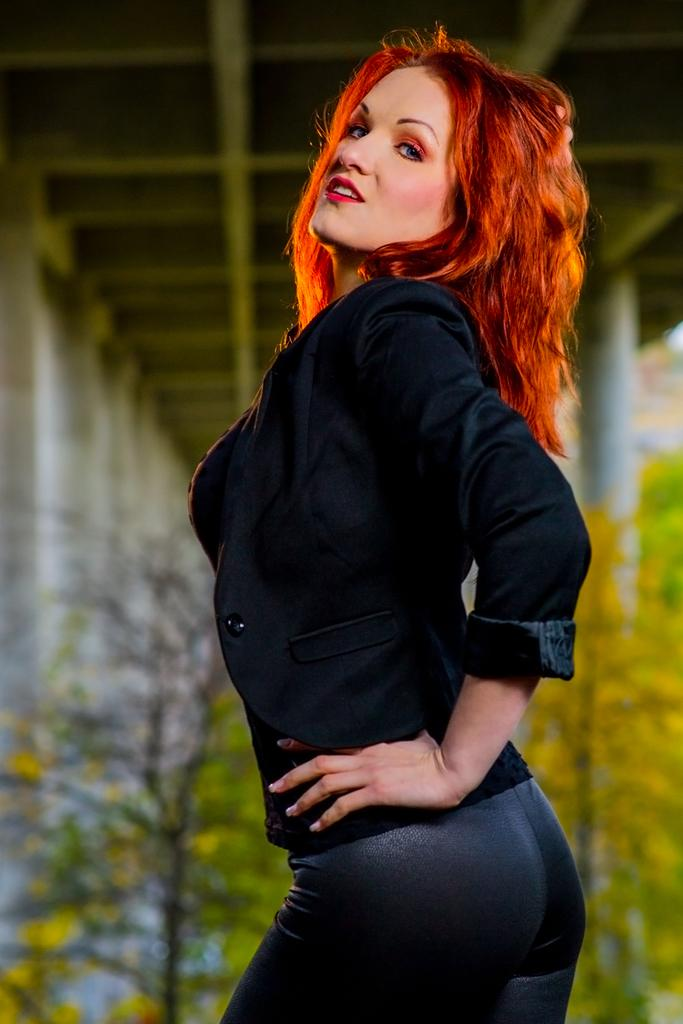What is the main subject of the image? There is a woman in the image. What is the woman wearing? The woman is wearing a black shirt and black trousers. What can be seen in the background of the image? There is a shed, pillars, trees, and plants in the background of the image. How many family members are present in the image? There is no indication of family members in the image, as it only features a woman. What expertise does the woman have in the image? There is no information about the woman's expertise in the image. 